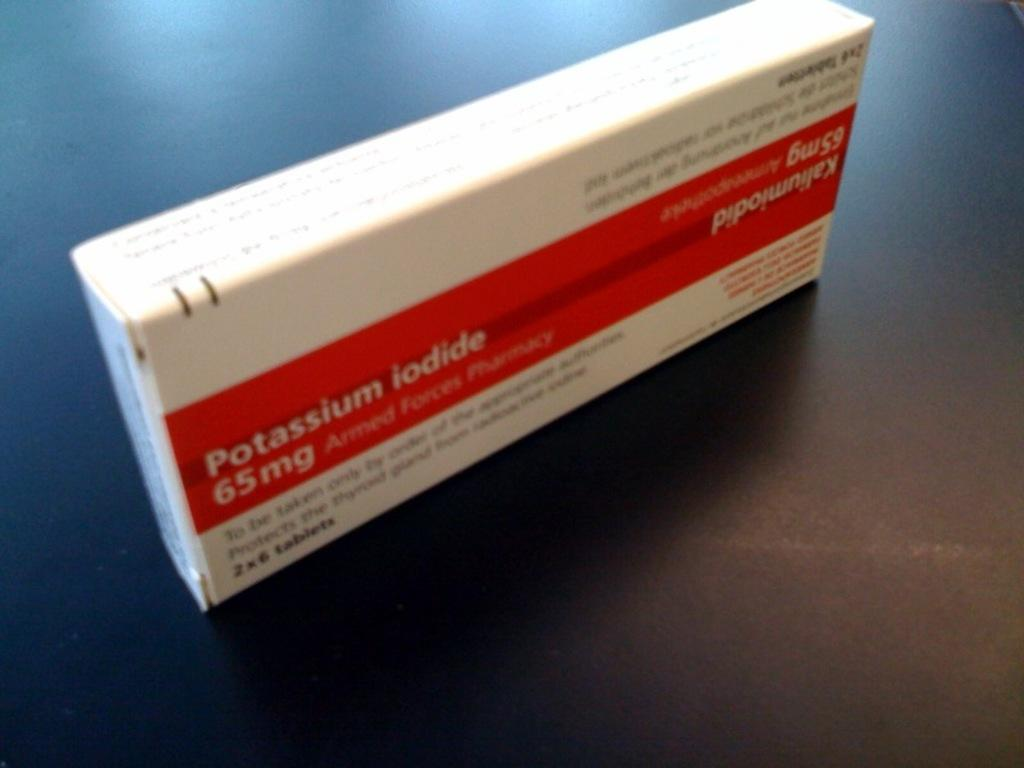<image>
Present a compact description of the photo's key features. 65 mg of Potassium Iodide is printed onto the front of this box. 